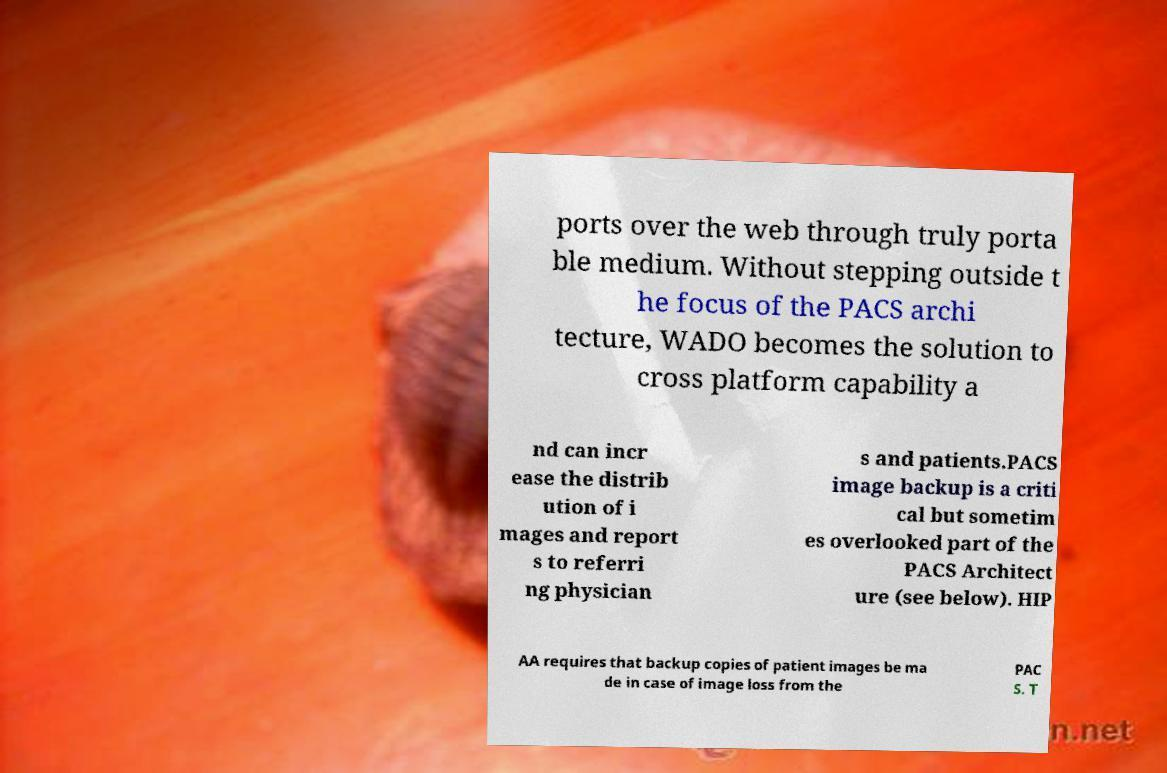For documentation purposes, I need the text within this image transcribed. Could you provide that? ports over the web through truly porta ble medium. Without stepping outside t he focus of the PACS archi tecture, WADO becomes the solution to cross platform capability a nd can incr ease the distrib ution of i mages and report s to referri ng physician s and patients.PACS image backup is a criti cal but sometim es overlooked part of the PACS Architect ure (see below). HIP AA requires that backup copies of patient images be ma de in case of image loss from the PAC S. T 